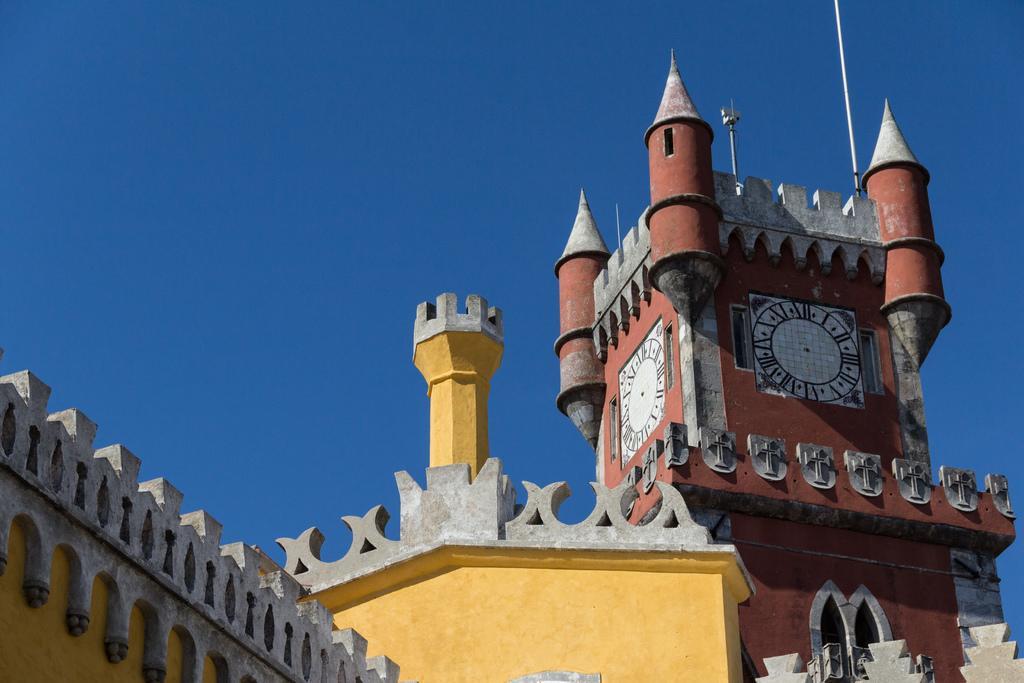How would you summarize this image in a sentence or two? Sky is in blue color. Here we can see building and clock tower. To this clock tower there are clocks. 